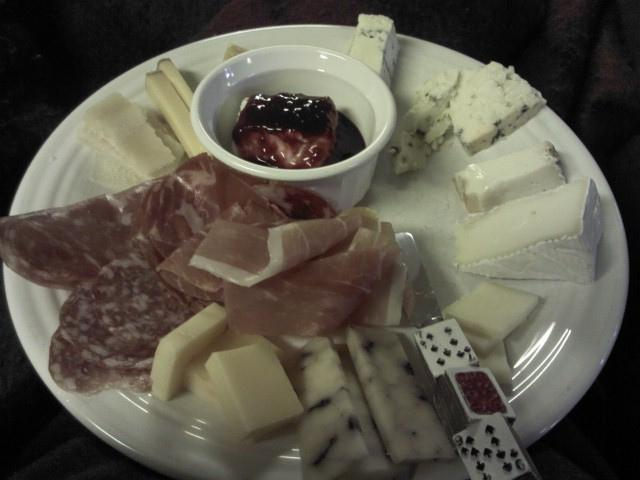What color is the back of the playing card printed cheese wedge?

Choices:
A) blue
B) green
C) red
D) purple red 